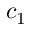Convert formula to latex. <formula><loc_0><loc_0><loc_500><loc_500>c _ { 1 }</formula> 